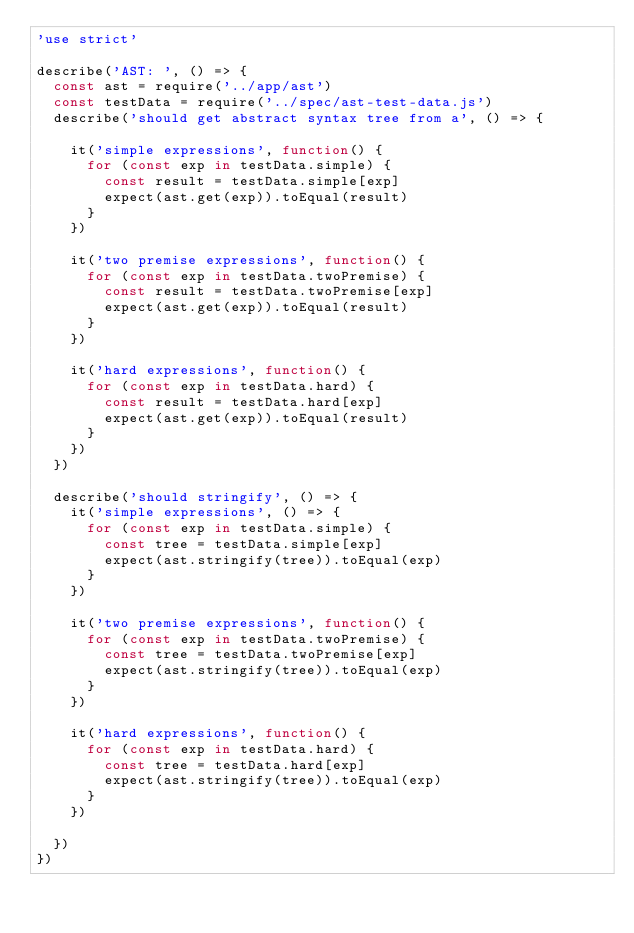Convert code to text. <code><loc_0><loc_0><loc_500><loc_500><_JavaScript_>'use strict'

describe('AST: ', () => {
  const ast = require('../app/ast')
  const testData = require('../spec/ast-test-data.js')
  describe('should get abstract syntax tree from a', () => {
    
    it('simple expressions', function() {
      for (const exp in testData.simple) {
        const result = testData.simple[exp]
        expect(ast.get(exp)).toEqual(result)
      }
    })

    it('two premise expressions', function() {
      for (const exp in testData.twoPremise) {
        const result = testData.twoPremise[exp]
        expect(ast.get(exp)).toEqual(result)
      }
    })

    it('hard expressions', function() {
      for (const exp in testData.hard) {
        const result = testData.hard[exp]
        expect(ast.get(exp)).toEqual(result)
      }
    })
  })  

  describe('should stringify', () => {
    it('simple expressions', () => {
      for (const exp in testData.simple) {
        const tree = testData.simple[exp]
        expect(ast.stringify(tree)).toEqual(exp)
      }
    })

    it('two premise expressions', function() {
      for (const exp in testData.twoPremise) {
        const tree = testData.twoPremise[exp]
        expect(ast.stringify(tree)).toEqual(exp)
      }
    })

    it('hard expressions', function() {
      for (const exp in testData.hard) {
        const tree = testData.hard[exp]
        expect(ast.stringify(tree)).toEqual(exp)
      }
    })
    
  })
})
</code> 